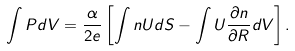Convert formula to latex. <formula><loc_0><loc_0><loc_500><loc_500>\int { P } d V = \frac { \alpha } { 2 e } \left [ \int n U d { S } - \int U \frac { \partial n } { \partial { R } } d V \right ] .</formula> 